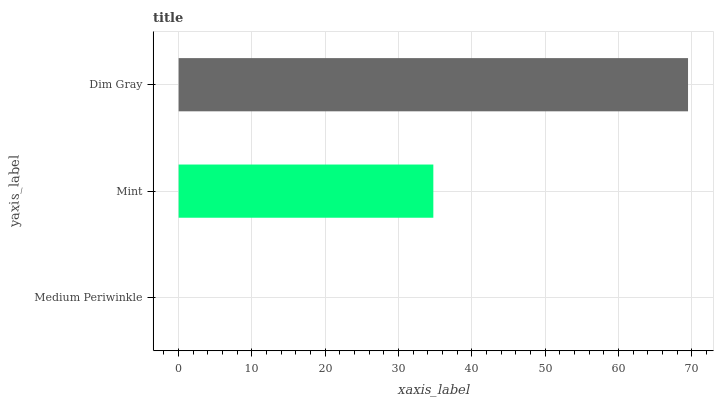Is Medium Periwinkle the minimum?
Answer yes or no. Yes. Is Dim Gray the maximum?
Answer yes or no. Yes. Is Mint the minimum?
Answer yes or no. No. Is Mint the maximum?
Answer yes or no. No. Is Mint greater than Medium Periwinkle?
Answer yes or no. Yes. Is Medium Periwinkle less than Mint?
Answer yes or no. Yes. Is Medium Periwinkle greater than Mint?
Answer yes or no. No. Is Mint less than Medium Periwinkle?
Answer yes or no. No. Is Mint the high median?
Answer yes or no. Yes. Is Mint the low median?
Answer yes or no. Yes. Is Dim Gray the high median?
Answer yes or no. No. Is Medium Periwinkle the low median?
Answer yes or no. No. 